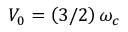<formula> <loc_0><loc_0><loc_500><loc_500>V _ { 0 } = \left ( 3 / 2 \right ) \omega _ { c }</formula> 